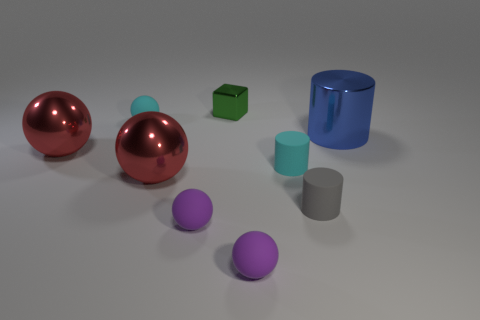Subtract all shiny spheres. How many spheres are left? 3 Subtract 1 spheres. How many spheres are left? 4 Add 1 blocks. How many objects exist? 10 Subtract all blocks. How many objects are left? 8 Subtract all red metal things. Subtract all purple matte objects. How many objects are left? 5 Add 2 small cyan matte cylinders. How many small cyan matte cylinders are left? 3 Add 1 big yellow metal objects. How many big yellow metal objects exist? 1 Subtract all gray cylinders. How many cylinders are left? 2 Subtract 0 green balls. How many objects are left? 9 Subtract all gray blocks. Subtract all blue spheres. How many blocks are left? 1 